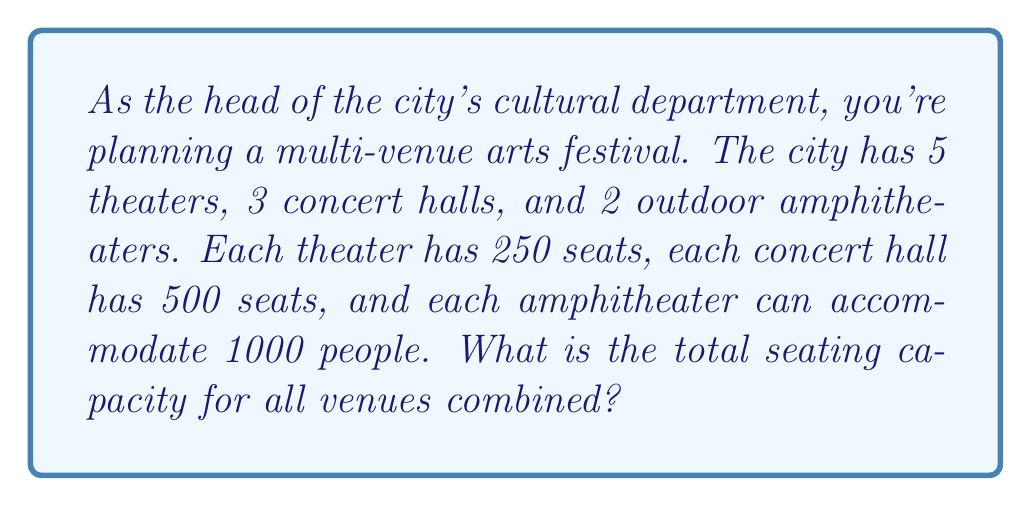Can you answer this question? Let's break this down step-by-step:

1. Calculate the total seating capacity for theaters:
   $$ 5 \text{ theaters} \times 250 \text{ seats} = 1250 \text{ seats} $$

2. Calculate the total seating capacity for concert halls:
   $$ 3 \text{ concert halls} \times 500 \text{ seats} = 1500 \text{ seats} $$

3. Calculate the total seating capacity for amphitheaters:
   $$ 2 \text{ amphitheaters} \times 1000 \text{ people} = 2000 \text{ people} $$

4. Sum up the total seating capacity for all venues:
   $$ 1250 + 1500 + 2000 = 4750 $$

Therefore, the total seating capacity for all venues combined is 4750.
Answer: 4750 seats 